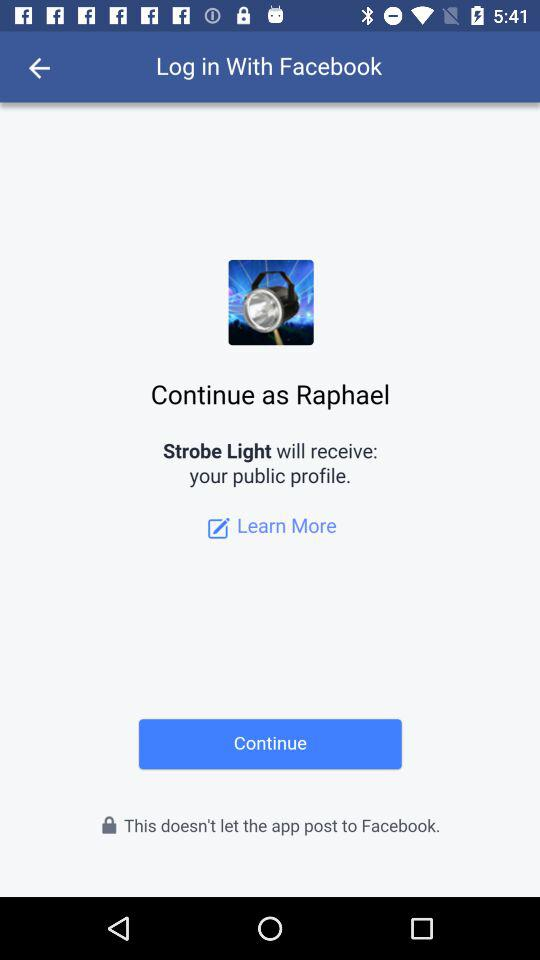What application will receive a public profile? The application that will receive a public profile is "Strobe Light". 